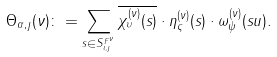Convert formula to latex. <formula><loc_0><loc_0><loc_500><loc_500>\Theta _ { \alpha , \jmath } ( \nu ) \colon = \sum _ { s \in S ^ { F ^ { \nu } } _ { \iota , \jmath } } \overline { \chi _ { \upsilon } ^ { ( \nu ) } ( s ) } \cdot \eta _ { \varsigma } ^ { ( \nu ) } ( s ) \cdot \omega _ { \psi } ^ { ( \nu ) } ( s u ) .</formula> 